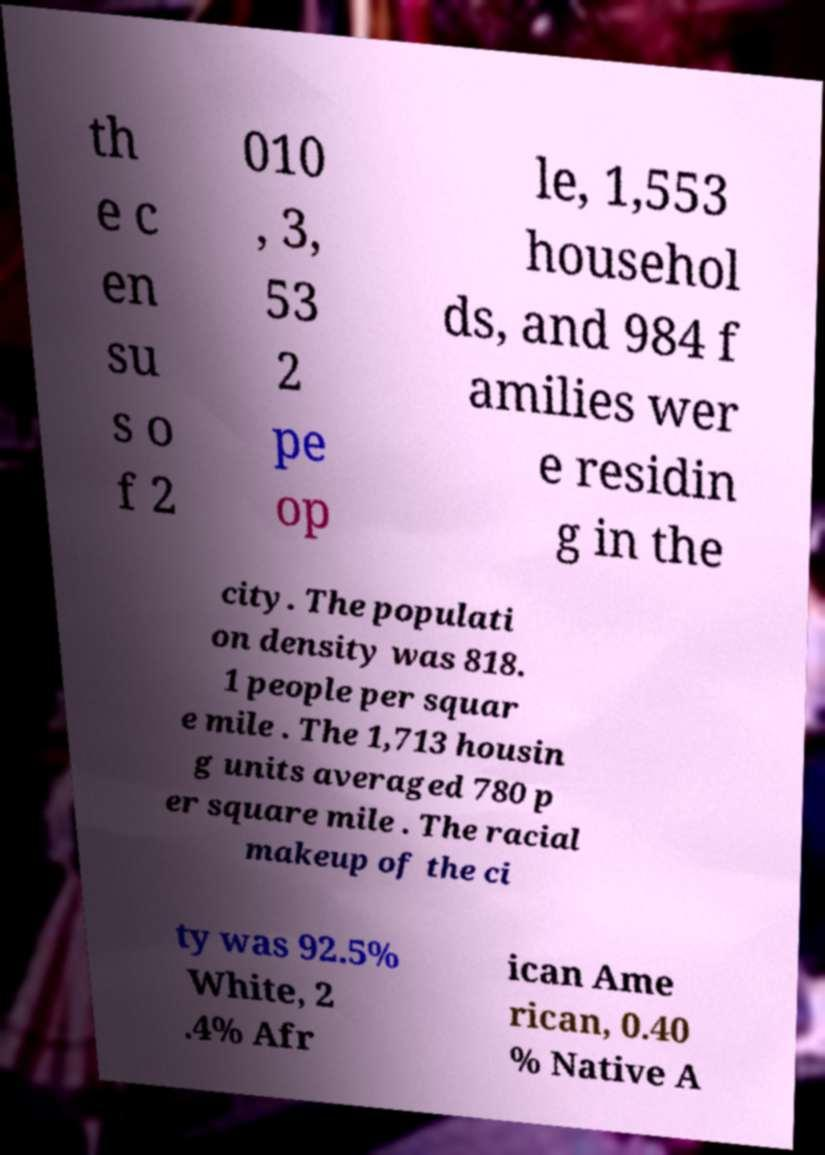Could you assist in decoding the text presented in this image and type it out clearly? th e c en su s o f 2 010 , 3, 53 2 pe op le, 1,553 househol ds, and 984 f amilies wer e residin g in the city. The populati on density was 818. 1 people per squar e mile . The 1,713 housin g units averaged 780 p er square mile . The racial makeup of the ci ty was 92.5% White, 2 .4% Afr ican Ame rican, 0.40 % Native A 